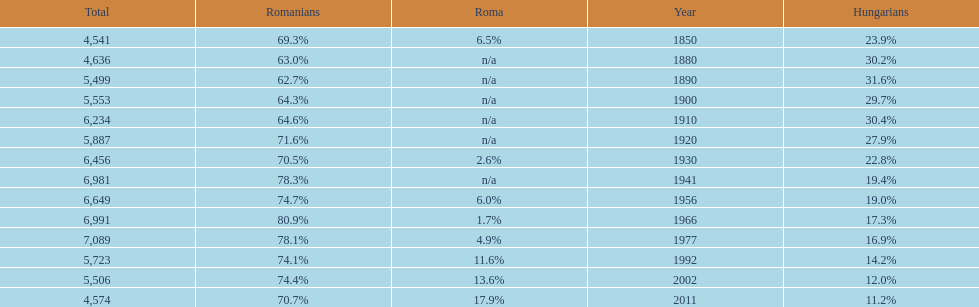4%? 1941. 